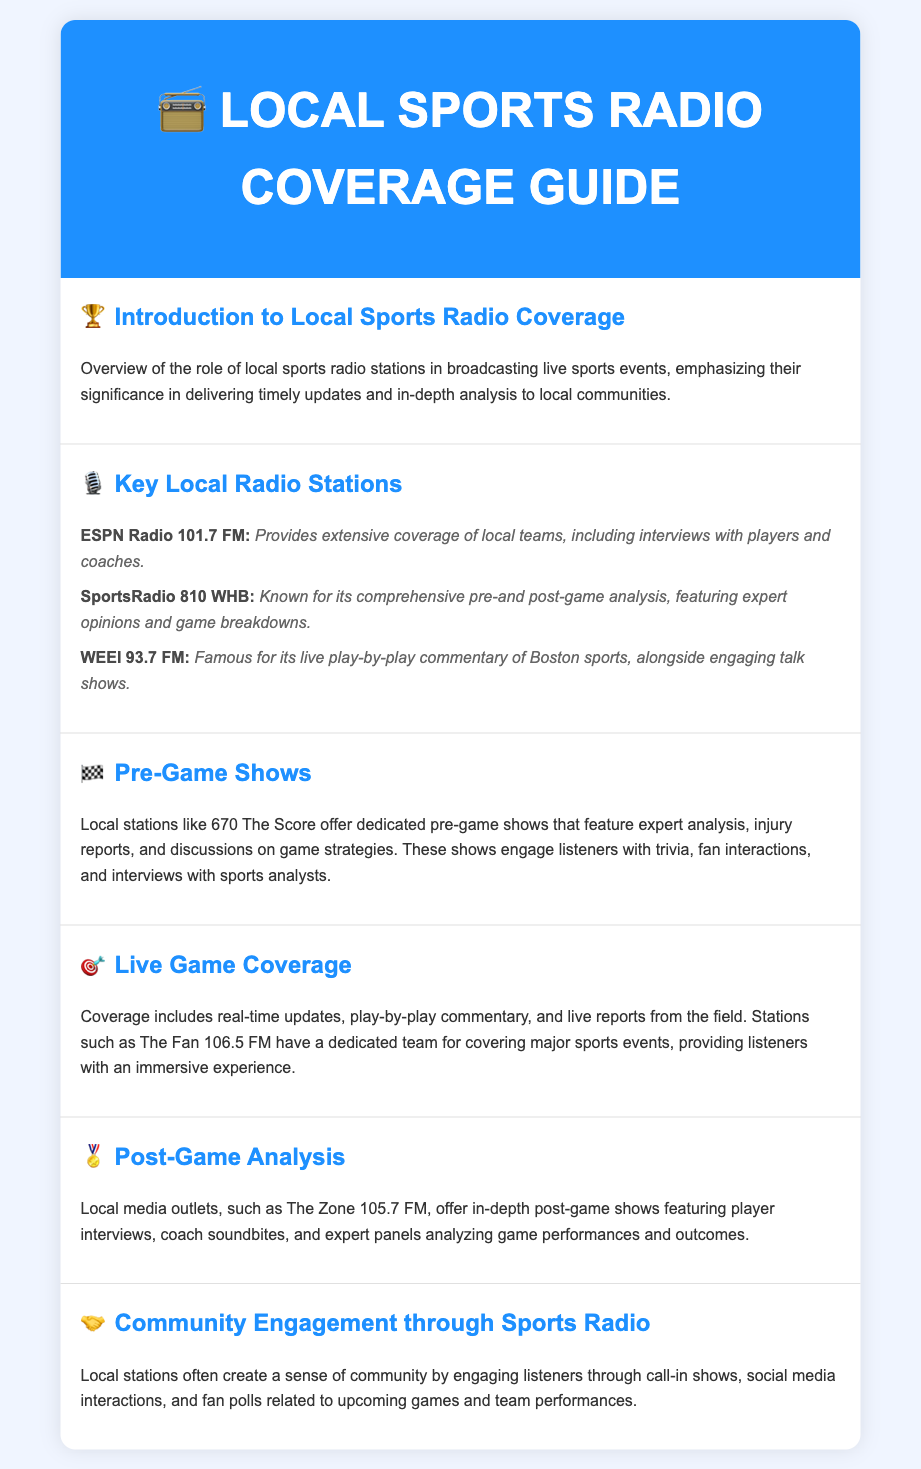What is the role of local sports radio stations? The document provides an overview of how local sports radio stations deliver timely updates and in-depth analysis to local communities.
Answer: Deliver timely updates and in-depth analysis Which station is known for comprehensive pre-and post-game analysis? The document states that SportsRadio 810 WHB is known for its comprehensive pre-and post-game analysis.
Answer: SportsRadio 810 WHB What type of coverage does 670 The Score offer? The document explains that 670 The Score offers dedicated pre-game shows featuring expert analysis and game strategies.
Answer: Dedicated pre-game shows What do local stations provide during live game coverage? According to the document, live game coverage includes real-time updates and play-by-play commentary.
Answer: Real-time updates and play-by-play commentary Which station provides post-game analysis featuring expert panels? The document mentions that The Zone 105.7 FM offers in-depth post-game shows with expert panels.
Answer: The Zone 105.7 FM How do local stations engage with the community? The document describes that local stations create a sense of community through call-in shows and social media interactions.
Answer: Call-in shows and social media interactions 